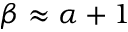<formula> <loc_0><loc_0><loc_500><loc_500>\beta \approx \alpha + 1</formula> 